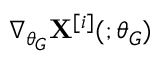Convert formula to latex. <formula><loc_0><loc_0><loc_500><loc_500>\nabla _ { \theta _ { G } } X ^ { [ i ] } ( ; \theta _ { G } )</formula> 